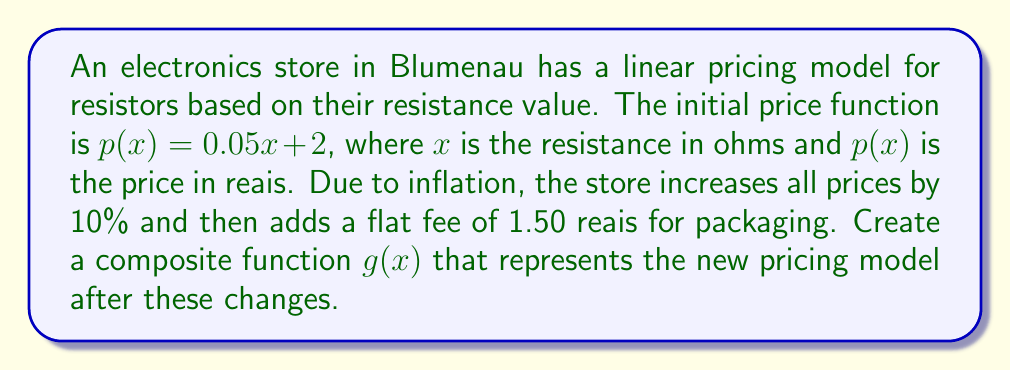Give your solution to this math problem. Let's approach this step-by-step:

1) The original function is $p(x) = 0.05x + 2$

2) To increase all prices by 10%, we multiply the function by 1.10:
   $f(x) = 1.10(0.05x + 2)$
   
3) Expanding this:
   $f(x) = 0.055x + 2.20$

4) Now, we need to add the flat fee of 1.50 reais. This is a vertical shift upward:
   $g(x) = f(x) + 1.50$

5) Substituting $f(x)$ with what we found in step 3:
   $g(x) = (0.055x + 2.20) + 1.50$

6) Simplifying:
   $g(x) = 0.055x + 3.70$

This function $g(x)$ represents the composite transformation of the original linear function, modeling the new pricing after the 10% increase and the addition of the packaging fee.
Answer: $g(x) = 0.055x + 3.70$ 